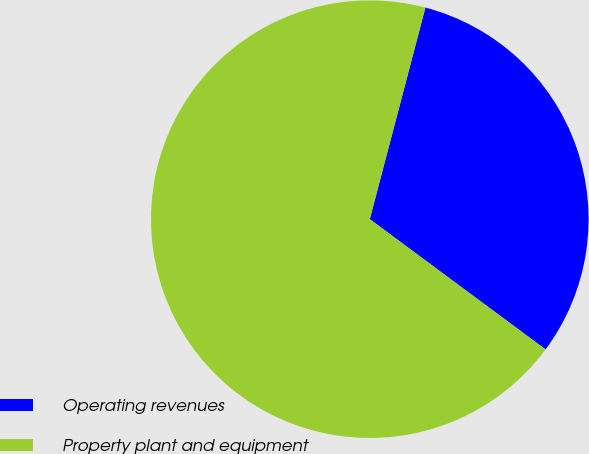Convert chart to OTSL. <chart><loc_0><loc_0><loc_500><loc_500><pie_chart><fcel>Operating revenues<fcel>Property plant and equipment<nl><fcel>31.06%<fcel>68.94%<nl></chart> 